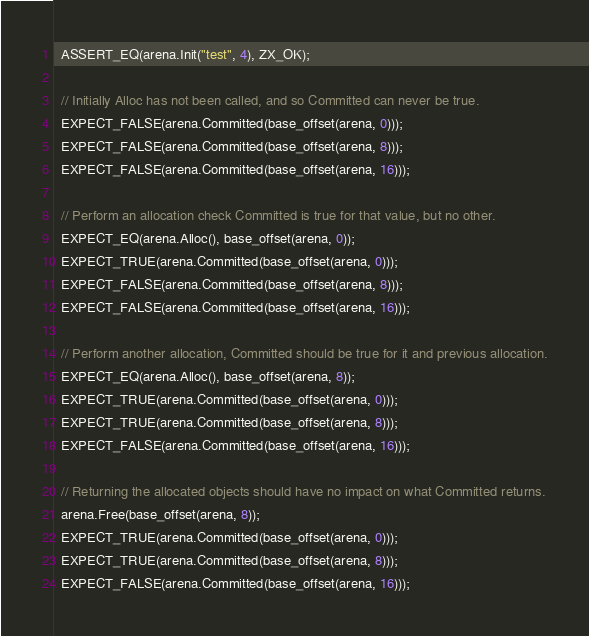Convert code to text. <code><loc_0><loc_0><loc_500><loc_500><_C++_>  ASSERT_EQ(arena.Init("test", 4), ZX_OK);

  // Initially Alloc has not been called, and so Committed can never be true.
  EXPECT_FALSE(arena.Committed(base_offset(arena, 0)));
  EXPECT_FALSE(arena.Committed(base_offset(arena, 8)));
  EXPECT_FALSE(arena.Committed(base_offset(arena, 16)));

  // Perform an allocation check Committed is true for that value, but no other.
  EXPECT_EQ(arena.Alloc(), base_offset(arena, 0));
  EXPECT_TRUE(arena.Committed(base_offset(arena, 0)));
  EXPECT_FALSE(arena.Committed(base_offset(arena, 8)));
  EXPECT_FALSE(arena.Committed(base_offset(arena, 16)));

  // Perform another allocation, Committed should be true for it and previous allocation.
  EXPECT_EQ(arena.Alloc(), base_offset(arena, 8));
  EXPECT_TRUE(arena.Committed(base_offset(arena, 0)));
  EXPECT_TRUE(arena.Committed(base_offset(arena, 8)));
  EXPECT_FALSE(arena.Committed(base_offset(arena, 16)));

  // Returning the allocated objects should have no impact on what Committed returns.
  arena.Free(base_offset(arena, 8));
  EXPECT_TRUE(arena.Committed(base_offset(arena, 0)));
  EXPECT_TRUE(arena.Committed(base_offset(arena, 8)));
  EXPECT_FALSE(arena.Committed(base_offset(arena, 16)));
</code> 